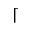<formula> <loc_0><loc_0><loc_500><loc_500>\lceil</formula> 